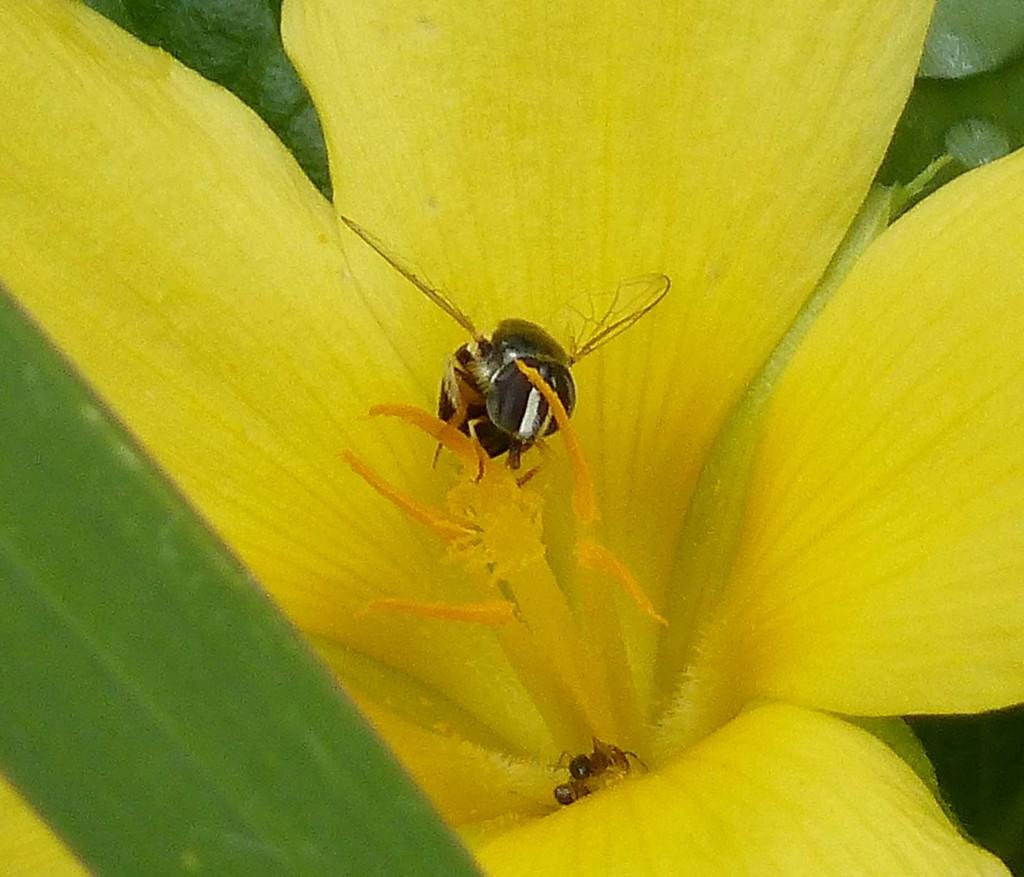What insect is on the flower in the foreground of the image? There is a bee on a yellow flower in the foreground of the image. How many ants are visible in the image? There are two ants in the image. What type of plant is present in the image? There is a green leaf in the image. What is the bee's mindset while resting in the cave in the image? There is no bee resting in a cave in the image; the bee is on a yellow flower. 